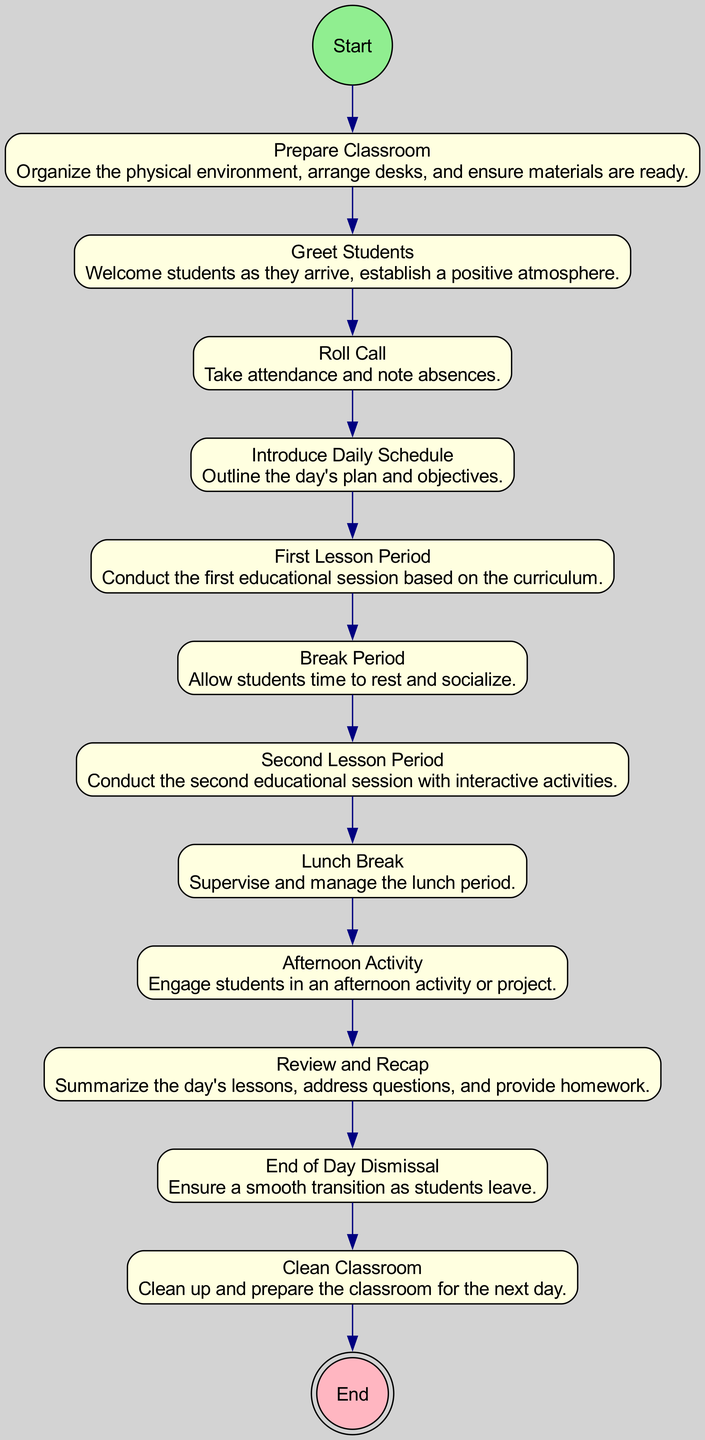What is the first action in the diagram? The first action in the diagram follows the "Start" node and is "Prepare Classroom." The flow of the diagram begins with this action, indicating that it is the first step in managing classroom activities for the day.
Answer: Prepare Classroom How many action nodes are present in the diagram? By counting the action nodes listed in the diagram, we find there are a total of eleven action nodes. These encompass various activities conducted throughout the day.
Answer: Eleven What follows the "Greet Students" action? The flow of the diagram indicates that after "Greet Students," the next action is "Roll Call." Following "Greet Students," the attendees are accounted for before proceeding to the next activity.
Answer: Roll Call Which activity is the last action before the "End of Day Dismissal"? According to the diagram, the action that occurs right before "End of Day Dismissal" is "Review and Recap." This step is designed to consolidate the day's learning before students leave.
Answer: Review and Recap What is the purpose of the "Clean Classroom" action? The action "Clean Classroom" is included as the last activity in the diagram, indicating its purpose is to tidy up and prepare the classroom for the next day, ensuring everything is in order for future use.
Answer: Prepare the classroom for the next day How many breaks are included in the daily schedule? Upon analyzing the diagram, there are two designated breaks within the daily schedule, namely the "Break Period" and "Lunch Break," providing students with necessary downtime throughout the day.
Answer: Two What action occurs after the "Second Lesson Period"? The diagram shows that immediately following the "Second Lesson Period," there is a "Lunch Break," allowing time for students to eat and relax before the afternoon activities.
Answer: Lunch Break Which action comes directly before the "End" node? The "End" node is preceded by the "Clean Classroom" action. This indicates that cleaning up the classroom is the last scheduled activity before the day concludes.
Answer: Clean Classroom 